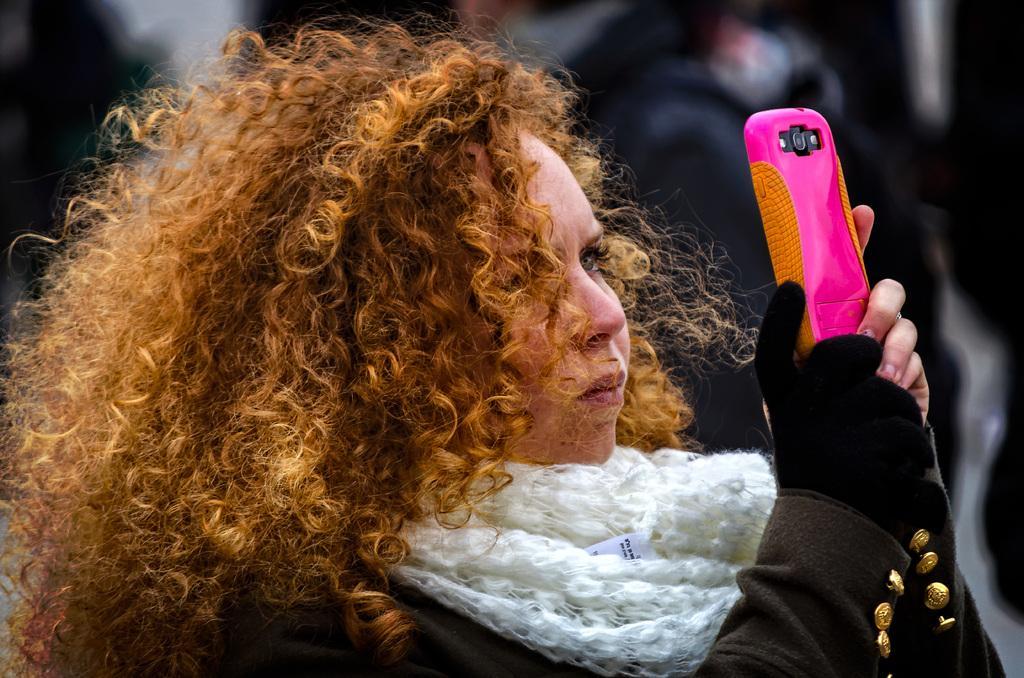In one or two sentences, can you explain what this image depicts? In this image i can see a woman is holding a mobile in her hands. 